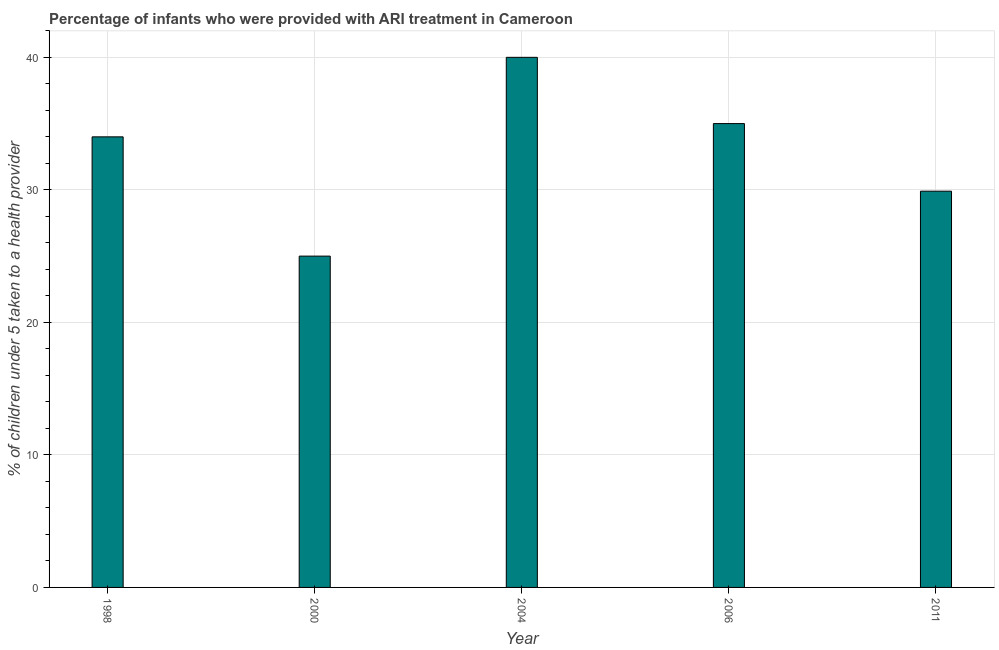Does the graph contain any zero values?
Your answer should be compact. No. Does the graph contain grids?
Make the answer very short. Yes. What is the title of the graph?
Give a very brief answer. Percentage of infants who were provided with ARI treatment in Cameroon. What is the label or title of the X-axis?
Your response must be concise. Year. What is the label or title of the Y-axis?
Provide a succinct answer. % of children under 5 taken to a health provider. Across all years, what is the maximum percentage of children who were provided with ari treatment?
Offer a very short reply. 40. In which year was the percentage of children who were provided with ari treatment maximum?
Your answer should be compact. 2004. In which year was the percentage of children who were provided with ari treatment minimum?
Provide a short and direct response. 2000. What is the sum of the percentage of children who were provided with ari treatment?
Keep it short and to the point. 163.9. What is the difference between the percentage of children who were provided with ari treatment in 2000 and 2006?
Keep it short and to the point. -10. What is the average percentage of children who were provided with ari treatment per year?
Give a very brief answer. 32.78. What is the median percentage of children who were provided with ari treatment?
Give a very brief answer. 34. Do a majority of the years between 2000 and 2004 (inclusive) have percentage of children who were provided with ari treatment greater than 8 %?
Keep it short and to the point. Yes. What is the ratio of the percentage of children who were provided with ari treatment in 1998 to that in 2011?
Offer a terse response. 1.14. Is the percentage of children who were provided with ari treatment in 2000 less than that in 2004?
Your answer should be compact. Yes. What is the difference between the highest and the lowest percentage of children who were provided with ari treatment?
Provide a short and direct response. 15. How many bars are there?
Your answer should be very brief. 5. What is the % of children under 5 taken to a health provider of 1998?
Provide a short and direct response. 34. What is the % of children under 5 taken to a health provider in 2004?
Keep it short and to the point. 40. What is the % of children under 5 taken to a health provider in 2006?
Provide a succinct answer. 35. What is the % of children under 5 taken to a health provider of 2011?
Your answer should be very brief. 29.9. What is the difference between the % of children under 5 taken to a health provider in 1998 and 2011?
Offer a terse response. 4.1. What is the difference between the % of children under 5 taken to a health provider in 2000 and 2011?
Your answer should be very brief. -4.9. What is the difference between the % of children under 5 taken to a health provider in 2004 and 2006?
Your answer should be very brief. 5. What is the ratio of the % of children under 5 taken to a health provider in 1998 to that in 2000?
Your answer should be compact. 1.36. What is the ratio of the % of children under 5 taken to a health provider in 1998 to that in 2004?
Offer a terse response. 0.85. What is the ratio of the % of children under 5 taken to a health provider in 1998 to that in 2006?
Keep it short and to the point. 0.97. What is the ratio of the % of children under 5 taken to a health provider in 1998 to that in 2011?
Your response must be concise. 1.14. What is the ratio of the % of children under 5 taken to a health provider in 2000 to that in 2004?
Keep it short and to the point. 0.62. What is the ratio of the % of children under 5 taken to a health provider in 2000 to that in 2006?
Your response must be concise. 0.71. What is the ratio of the % of children under 5 taken to a health provider in 2000 to that in 2011?
Your answer should be very brief. 0.84. What is the ratio of the % of children under 5 taken to a health provider in 2004 to that in 2006?
Your answer should be very brief. 1.14. What is the ratio of the % of children under 5 taken to a health provider in 2004 to that in 2011?
Offer a very short reply. 1.34. What is the ratio of the % of children under 5 taken to a health provider in 2006 to that in 2011?
Keep it short and to the point. 1.17. 